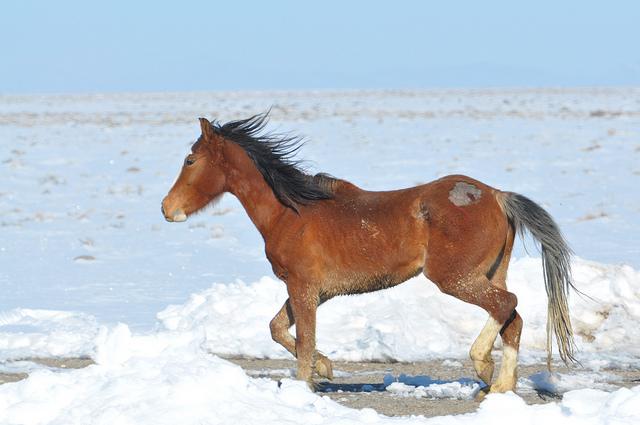Does the horse look tired?
Write a very short answer. No. What is running through the snow?
Concise answer only. Horse. Why does the horse have a bald patch on its hindquarters?
Short answer required. Old age. Is this horse overweight?
Keep it brief. No. 